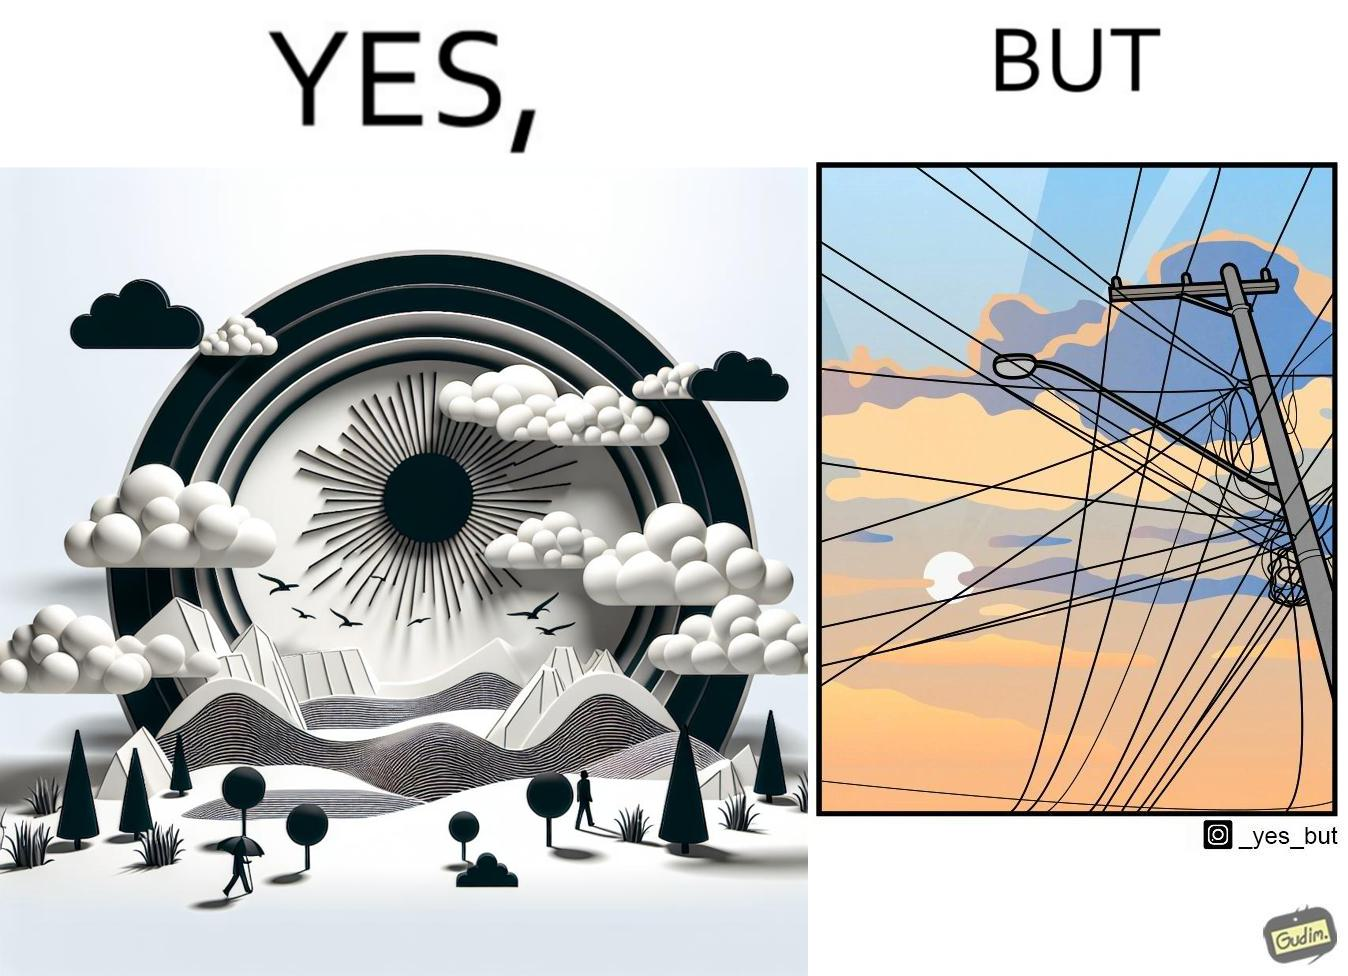Provide a description of this image. The image is ironic, because in the first image clear sky is visible but in the second image the same view is getting blocked due to the electricity pole 